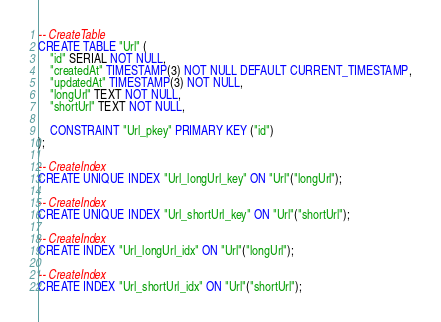Convert code to text. <code><loc_0><loc_0><loc_500><loc_500><_SQL_>-- CreateTable
CREATE TABLE "Url" (
    "id" SERIAL NOT NULL,
    "createdAt" TIMESTAMP(3) NOT NULL DEFAULT CURRENT_TIMESTAMP,
    "updatedAt" TIMESTAMP(3) NOT NULL,
    "longUrl" TEXT NOT NULL,
    "shortUrl" TEXT NOT NULL,

    CONSTRAINT "Url_pkey" PRIMARY KEY ("id")
);

-- CreateIndex
CREATE UNIQUE INDEX "Url_longUrl_key" ON "Url"("longUrl");

-- CreateIndex
CREATE UNIQUE INDEX "Url_shortUrl_key" ON "Url"("shortUrl");

-- CreateIndex
CREATE INDEX "Url_longUrl_idx" ON "Url"("longUrl");

-- CreateIndex
CREATE INDEX "Url_shortUrl_idx" ON "Url"("shortUrl");
</code> 